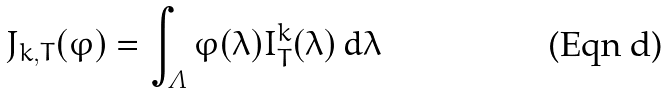<formula> <loc_0><loc_0><loc_500><loc_500>J _ { k , T } ( \varphi ) = \int _ { \varLambda } \varphi ( \lambda ) I _ { T } ^ { k } ( \lambda ) \, d \lambda</formula> 